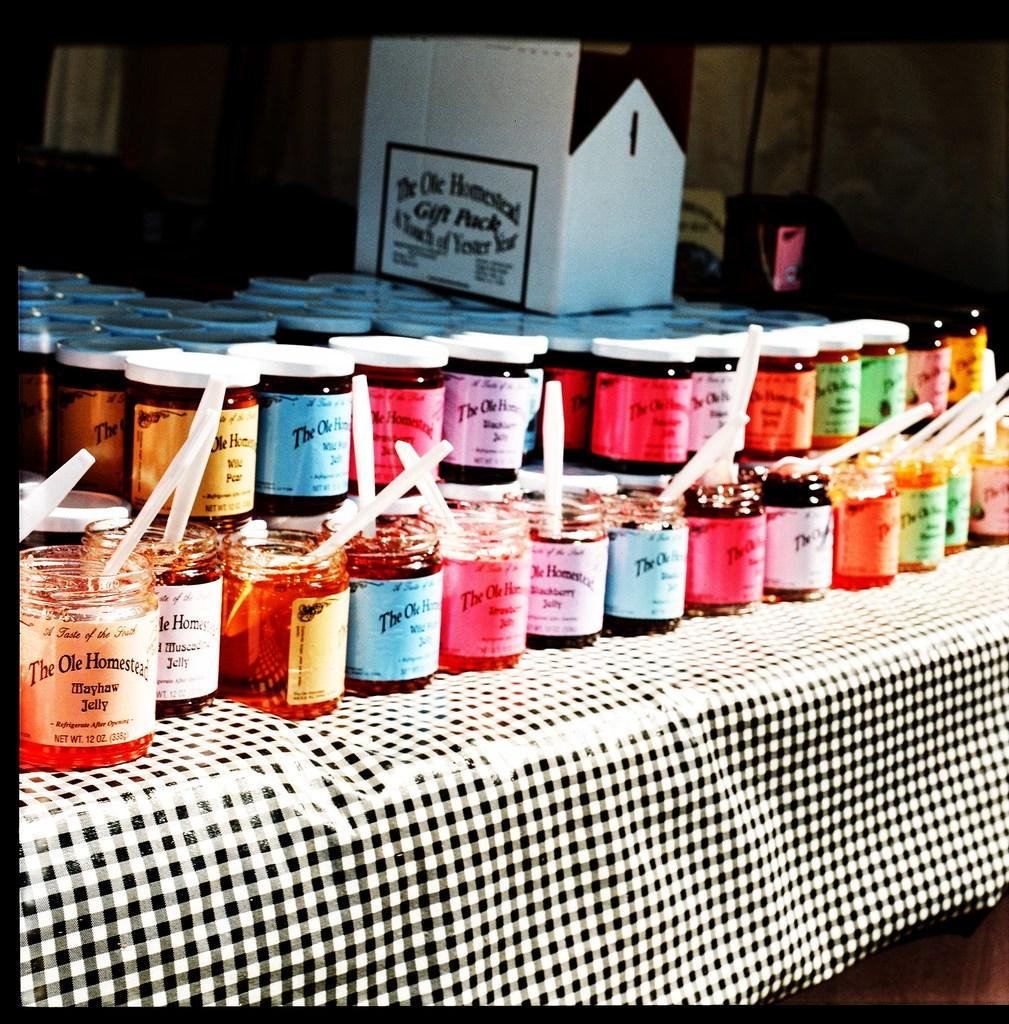<image>
Provide a brief description of the given image. Table with bottles of jam on it with one that says THE OLE HOMESTEAD. 